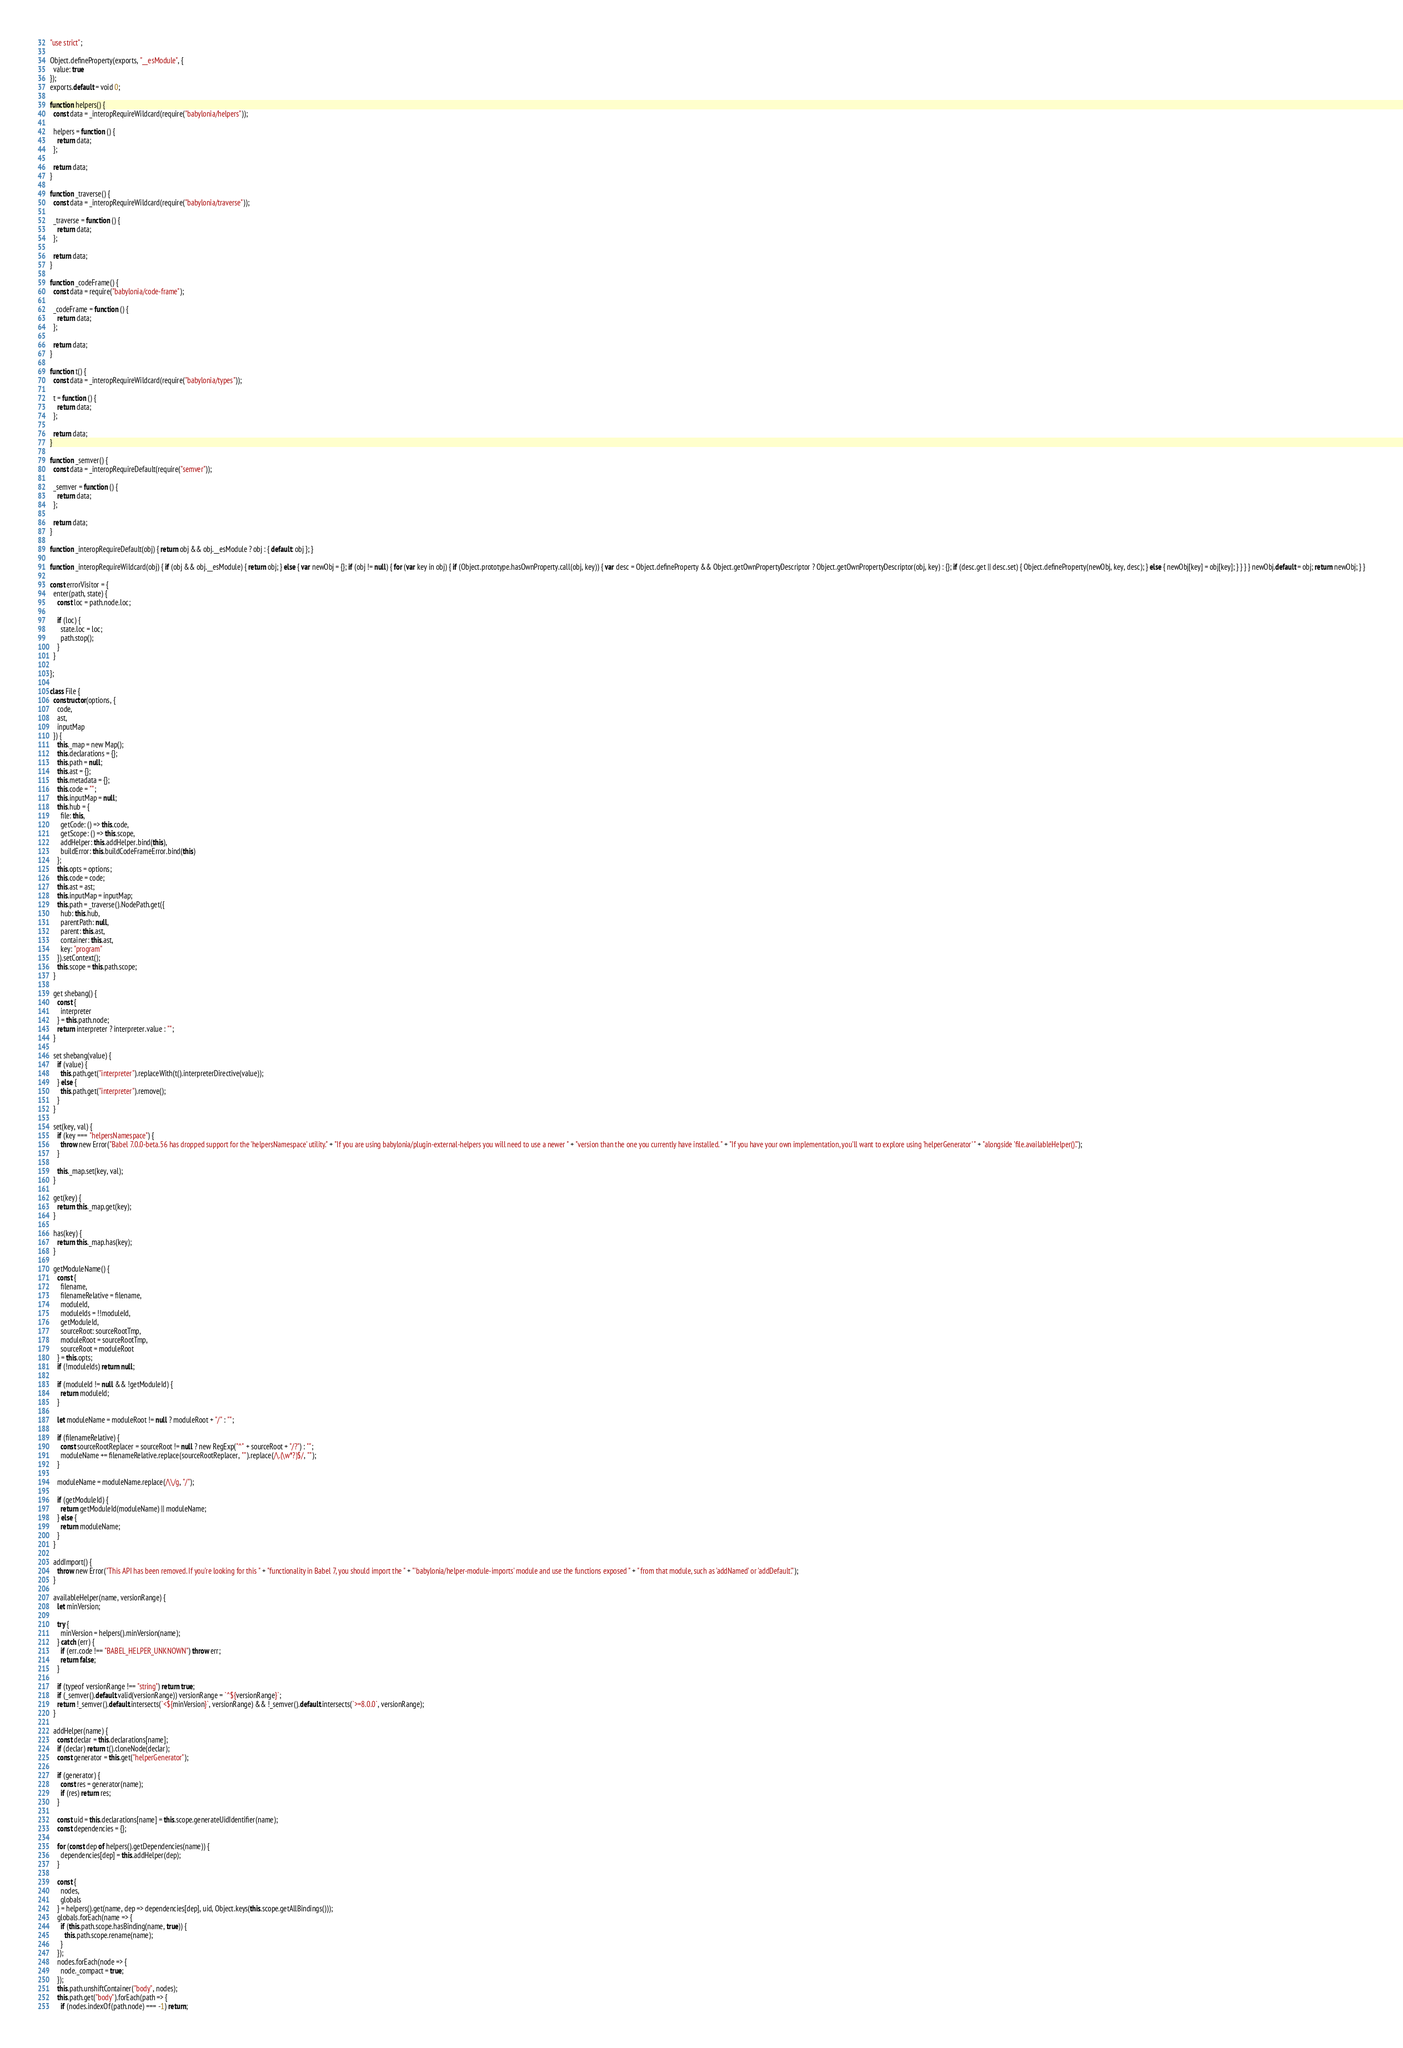Convert code to text. <code><loc_0><loc_0><loc_500><loc_500><_JavaScript_>"use strict";

Object.defineProperty(exports, "__esModule", {
  value: true
});
exports.default = void 0;

function helpers() {
  const data = _interopRequireWildcard(require("babylonia/helpers"));

  helpers = function () {
    return data;
  };

  return data;
}

function _traverse() {
  const data = _interopRequireWildcard(require("babylonia/traverse"));

  _traverse = function () {
    return data;
  };

  return data;
}

function _codeFrame() {
  const data = require("babylonia/code-frame");

  _codeFrame = function () {
    return data;
  };

  return data;
}

function t() {
  const data = _interopRequireWildcard(require("babylonia/types"));

  t = function () {
    return data;
  };

  return data;
}

function _semver() {
  const data = _interopRequireDefault(require("semver"));

  _semver = function () {
    return data;
  };

  return data;
}

function _interopRequireDefault(obj) { return obj && obj.__esModule ? obj : { default: obj }; }

function _interopRequireWildcard(obj) { if (obj && obj.__esModule) { return obj; } else { var newObj = {}; if (obj != null) { for (var key in obj) { if (Object.prototype.hasOwnProperty.call(obj, key)) { var desc = Object.defineProperty && Object.getOwnPropertyDescriptor ? Object.getOwnPropertyDescriptor(obj, key) : {}; if (desc.get || desc.set) { Object.defineProperty(newObj, key, desc); } else { newObj[key] = obj[key]; } } } } newObj.default = obj; return newObj; } }

const errorVisitor = {
  enter(path, state) {
    const loc = path.node.loc;

    if (loc) {
      state.loc = loc;
      path.stop();
    }
  }

};

class File {
  constructor(options, {
    code,
    ast,
    inputMap
  }) {
    this._map = new Map();
    this.declarations = {};
    this.path = null;
    this.ast = {};
    this.metadata = {};
    this.code = "";
    this.inputMap = null;
    this.hub = {
      file: this,
      getCode: () => this.code,
      getScope: () => this.scope,
      addHelper: this.addHelper.bind(this),
      buildError: this.buildCodeFrameError.bind(this)
    };
    this.opts = options;
    this.code = code;
    this.ast = ast;
    this.inputMap = inputMap;
    this.path = _traverse().NodePath.get({
      hub: this.hub,
      parentPath: null,
      parent: this.ast,
      container: this.ast,
      key: "program"
    }).setContext();
    this.scope = this.path.scope;
  }

  get shebang() {
    const {
      interpreter
    } = this.path.node;
    return interpreter ? interpreter.value : "";
  }

  set shebang(value) {
    if (value) {
      this.path.get("interpreter").replaceWith(t().interpreterDirective(value));
    } else {
      this.path.get("interpreter").remove();
    }
  }

  set(key, val) {
    if (key === "helpersNamespace") {
      throw new Error("Babel 7.0.0-beta.56 has dropped support for the 'helpersNamespace' utility." + "If you are using babylonia/plugin-external-helpers you will need to use a newer " + "version than the one you currently have installed. " + "If you have your own implementation, you'll want to explore using 'helperGenerator' " + "alongside 'file.availableHelper()'.");
    }

    this._map.set(key, val);
  }

  get(key) {
    return this._map.get(key);
  }

  has(key) {
    return this._map.has(key);
  }

  getModuleName() {
    const {
      filename,
      filenameRelative = filename,
      moduleId,
      moduleIds = !!moduleId,
      getModuleId,
      sourceRoot: sourceRootTmp,
      moduleRoot = sourceRootTmp,
      sourceRoot = moduleRoot
    } = this.opts;
    if (!moduleIds) return null;

    if (moduleId != null && !getModuleId) {
      return moduleId;
    }

    let moduleName = moduleRoot != null ? moduleRoot + "/" : "";

    if (filenameRelative) {
      const sourceRootReplacer = sourceRoot != null ? new RegExp("^" + sourceRoot + "/?") : "";
      moduleName += filenameRelative.replace(sourceRootReplacer, "").replace(/\.(\w*?)$/, "");
    }

    moduleName = moduleName.replace(/\\/g, "/");

    if (getModuleId) {
      return getModuleId(moduleName) || moduleName;
    } else {
      return moduleName;
    }
  }

  addImport() {
    throw new Error("This API has been removed. If you're looking for this " + "functionality in Babel 7, you should import the " + "'babylonia/helper-module-imports' module and use the functions exposed " + " from that module, such as 'addNamed' or 'addDefault'.");
  }

  availableHelper(name, versionRange) {
    let minVersion;

    try {
      minVersion = helpers().minVersion(name);
    } catch (err) {
      if (err.code !== "BABEL_HELPER_UNKNOWN") throw err;
      return false;
    }

    if (typeof versionRange !== "string") return true;
    if (_semver().default.valid(versionRange)) versionRange = `^${versionRange}`;
    return !_semver().default.intersects(`<${minVersion}`, versionRange) && !_semver().default.intersects(`>=8.0.0`, versionRange);
  }

  addHelper(name) {
    const declar = this.declarations[name];
    if (declar) return t().cloneNode(declar);
    const generator = this.get("helperGenerator");

    if (generator) {
      const res = generator(name);
      if (res) return res;
    }

    const uid = this.declarations[name] = this.scope.generateUidIdentifier(name);
    const dependencies = {};

    for (const dep of helpers().getDependencies(name)) {
      dependencies[dep] = this.addHelper(dep);
    }

    const {
      nodes,
      globals
    } = helpers().get(name, dep => dependencies[dep], uid, Object.keys(this.scope.getAllBindings()));
    globals.forEach(name => {
      if (this.path.scope.hasBinding(name, true)) {
        this.path.scope.rename(name);
      }
    });
    nodes.forEach(node => {
      node._compact = true;
    });
    this.path.unshiftContainer("body", nodes);
    this.path.get("body").forEach(path => {
      if (nodes.indexOf(path.node) === -1) return;</code> 